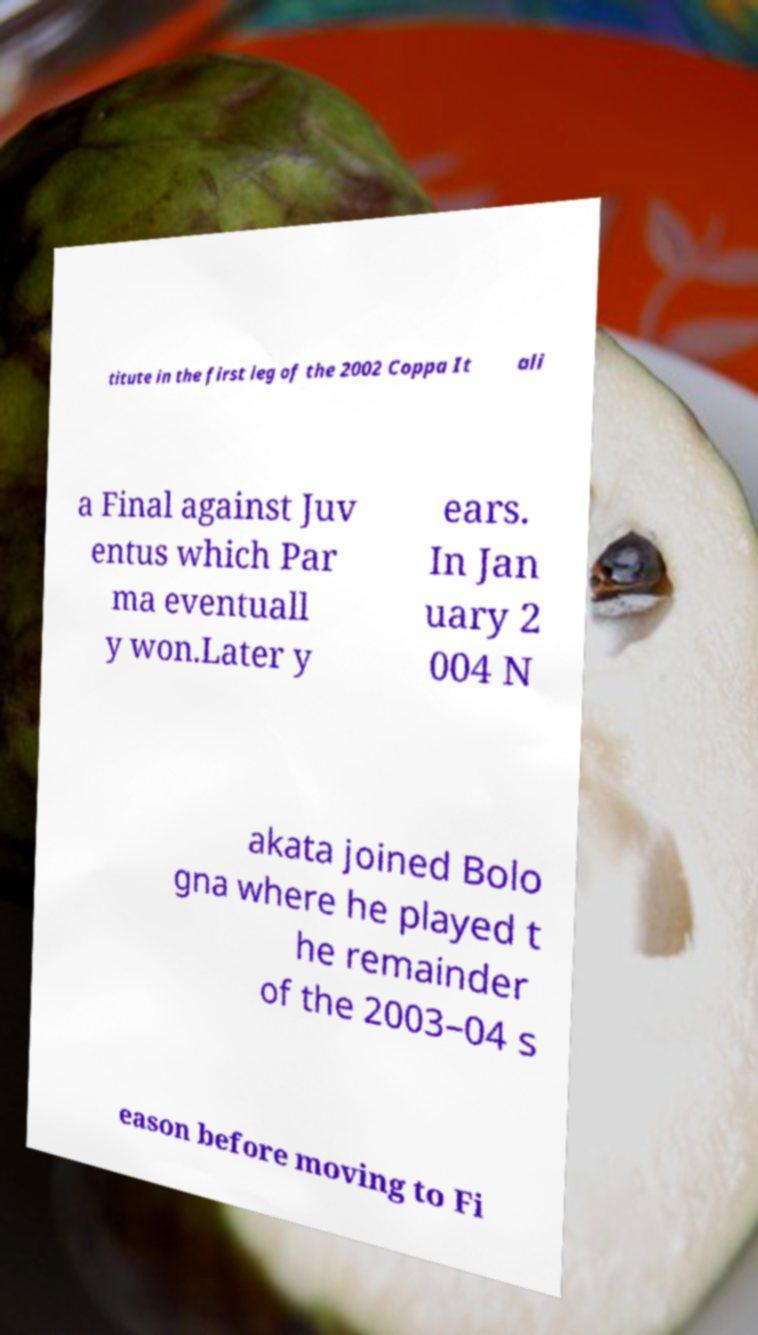There's text embedded in this image that I need extracted. Can you transcribe it verbatim? titute in the first leg of the 2002 Coppa It ali a Final against Juv entus which Par ma eventuall y won.Later y ears. In Jan uary 2 004 N akata joined Bolo gna where he played t he remainder of the 2003–04 s eason before moving to Fi 